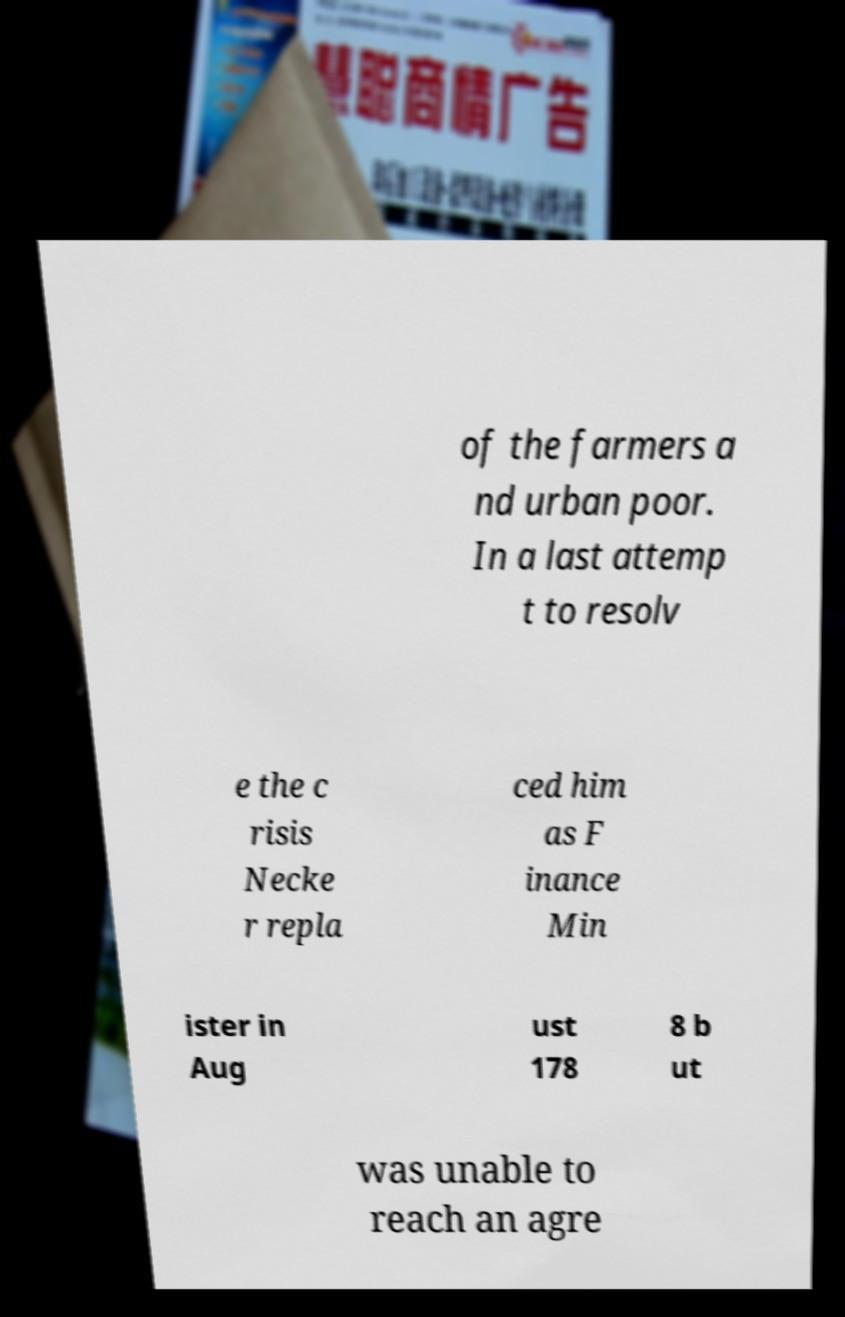Can you read and provide the text displayed in the image?This photo seems to have some interesting text. Can you extract and type it out for me? of the farmers a nd urban poor. In a last attemp t to resolv e the c risis Necke r repla ced him as F inance Min ister in Aug ust 178 8 b ut was unable to reach an agre 